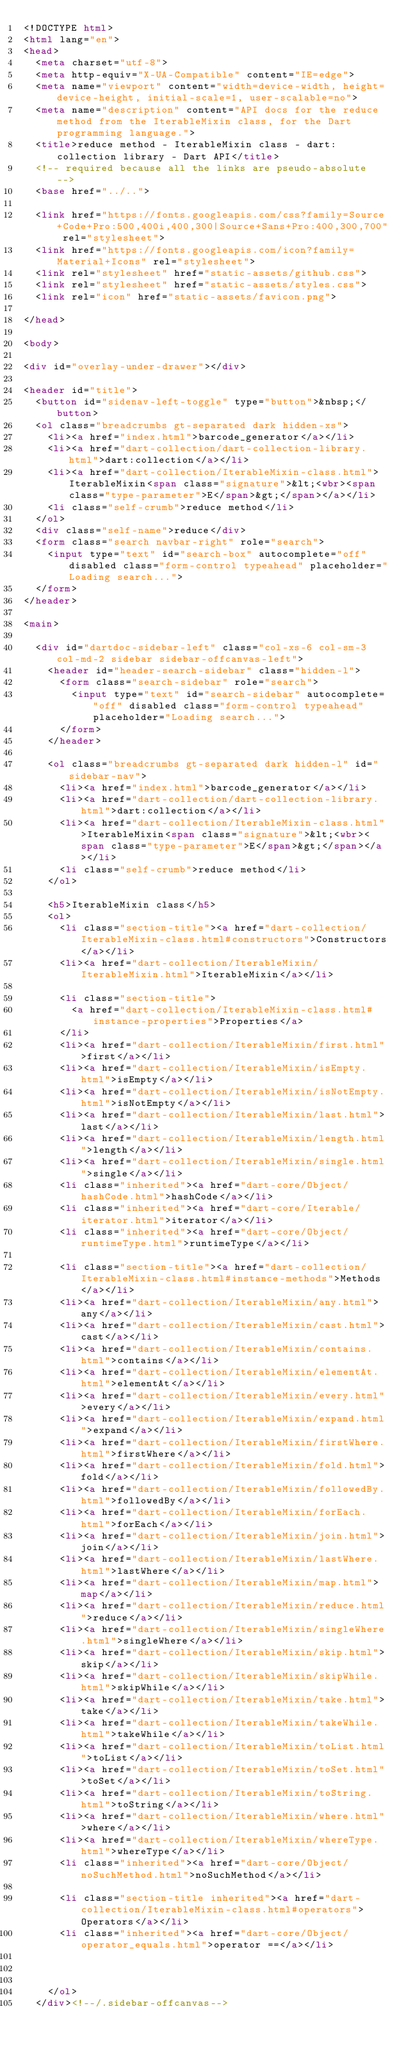Convert code to text. <code><loc_0><loc_0><loc_500><loc_500><_HTML_><!DOCTYPE html>
<html lang="en">
<head>
  <meta charset="utf-8">
  <meta http-equiv="X-UA-Compatible" content="IE=edge">
  <meta name="viewport" content="width=device-width, height=device-height, initial-scale=1, user-scalable=no">
  <meta name="description" content="API docs for the reduce method from the IterableMixin class, for the Dart programming language.">
  <title>reduce method - IterableMixin class - dart:collection library - Dart API</title>
  <!-- required because all the links are pseudo-absolute -->
  <base href="../..">

  <link href="https://fonts.googleapis.com/css?family=Source+Code+Pro:500,400i,400,300|Source+Sans+Pro:400,300,700" rel="stylesheet">
  <link href="https://fonts.googleapis.com/icon?family=Material+Icons" rel="stylesheet">
  <link rel="stylesheet" href="static-assets/github.css">
  <link rel="stylesheet" href="static-assets/styles.css">
  <link rel="icon" href="static-assets/favicon.png">
  
</head>

<body>

<div id="overlay-under-drawer"></div>

<header id="title">
  <button id="sidenav-left-toggle" type="button">&nbsp;</button>
  <ol class="breadcrumbs gt-separated dark hidden-xs">
    <li><a href="index.html">barcode_generator</a></li>
    <li><a href="dart-collection/dart-collection-library.html">dart:collection</a></li>
    <li><a href="dart-collection/IterableMixin-class.html">IterableMixin<span class="signature">&lt;<wbr><span class="type-parameter">E</span>&gt;</span></a></li>
    <li class="self-crumb">reduce method</li>
  </ol>
  <div class="self-name">reduce</div>
  <form class="search navbar-right" role="search">
    <input type="text" id="search-box" autocomplete="off" disabled class="form-control typeahead" placeholder="Loading search...">
  </form>
</header>

<main>

  <div id="dartdoc-sidebar-left" class="col-xs-6 col-sm-3 col-md-2 sidebar sidebar-offcanvas-left">
    <header id="header-search-sidebar" class="hidden-l">
      <form class="search-sidebar" role="search">
        <input type="text" id="search-sidebar" autocomplete="off" disabled class="form-control typeahead" placeholder="Loading search...">
      </form>
    </header>
    
    <ol class="breadcrumbs gt-separated dark hidden-l" id="sidebar-nav">
      <li><a href="index.html">barcode_generator</a></li>
      <li><a href="dart-collection/dart-collection-library.html">dart:collection</a></li>
      <li><a href="dart-collection/IterableMixin-class.html">IterableMixin<span class="signature">&lt;<wbr><span class="type-parameter">E</span>&gt;</span></a></li>
      <li class="self-crumb">reduce method</li>
    </ol>
    
    <h5>IterableMixin class</h5>
    <ol>
      <li class="section-title"><a href="dart-collection/IterableMixin-class.html#constructors">Constructors</a></li>
      <li><a href="dart-collection/IterableMixin/IterableMixin.html">IterableMixin</a></li>
    
      <li class="section-title">
        <a href="dart-collection/IterableMixin-class.html#instance-properties">Properties</a>
      </li>
      <li><a href="dart-collection/IterableMixin/first.html">first</a></li>
      <li><a href="dart-collection/IterableMixin/isEmpty.html">isEmpty</a></li>
      <li><a href="dart-collection/IterableMixin/isNotEmpty.html">isNotEmpty</a></li>
      <li><a href="dart-collection/IterableMixin/last.html">last</a></li>
      <li><a href="dart-collection/IterableMixin/length.html">length</a></li>
      <li><a href="dart-collection/IterableMixin/single.html">single</a></li>
      <li class="inherited"><a href="dart-core/Object/hashCode.html">hashCode</a></li>
      <li class="inherited"><a href="dart-core/Iterable/iterator.html">iterator</a></li>
      <li class="inherited"><a href="dart-core/Object/runtimeType.html">runtimeType</a></li>
    
      <li class="section-title"><a href="dart-collection/IterableMixin-class.html#instance-methods">Methods</a></li>
      <li><a href="dart-collection/IterableMixin/any.html">any</a></li>
      <li><a href="dart-collection/IterableMixin/cast.html">cast</a></li>
      <li><a href="dart-collection/IterableMixin/contains.html">contains</a></li>
      <li><a href="dart-collection/IterableMixin/elementAt.html">elementAt</a></li>
      <li><a href="dart-collection/IterableMixin/every.html">every</a></li>
      <li><a href="dart-collection/IterableMixin/expand.html">expand</a></li>
      <li><a href="dart-collection/IterableMixin/firstWhere.html">firstWhere</a></li>
      <li><a href="dart-collection/IterableMixin/fold.html">fold</a></li>
      <li><a href="dart-collection/IterableMixin/followedBy.html">followedBy</a></li>
      <li><a href="dart-collection/IterableMixin/forEach.html">forEach</a></li>
      <li><a href="dart-collection/IterableMixin/join.html">join</a></li>
      <li><a href="dart-collection/IterableMixin/lastWhere.html">lastWhere</a></li>
      <li><a href="dart-collection/IterableMixin/map.html">map</a></li>
      <li><a href="dart-collection/IterableMixin/reduce.html">reduce</a></li>
      <li><a href="dart-collection/IterableMixin/singleWhere.html">singleWhere</a></li>
      <li><a href="dart-collection/IterableMixin/skip.html">skip</a></li>
      <li><a href="dart-collection/IterableMixin/skipWhile.html">skipWhile</a></li>
      <li><a href="dart-collection/IterableMixin/take.html">take</a></li>
      <li><a href="dart-collection/IterableMixin/takeWhile.html">takeWhile</a></li>
      <li><a href="dart-collection/IterableMixin/toList.html">toList</a></li>
      <li><a href="dart-collection/IterableMixin/toSet.html">toSet</a></li>
      <li><a href="dart-collection/IterableMixin/toString.html">toString</a></li>
      <li><a href="dart-collection/IterableMixin/where.html">where</a></li>
      <li><a href="dart-collection/IterableMixin/whereType.html">whereType</a></li>
      <li class="inherited"><a href="dart-core/Object/noSuchMethod.html">noSuchMethod</a></li>
    
      <li class="section-title inherited"><a href="dart-collection/IterableMixin-class.html#operators">Operators</a></li>
      <li class="inherited"><a href="dart-core/Object/operator_equals.html">operator ==</a></li>
    
    
    
    </ol>
  </div><!--/.sidebar-offcanvas-->
</code> 